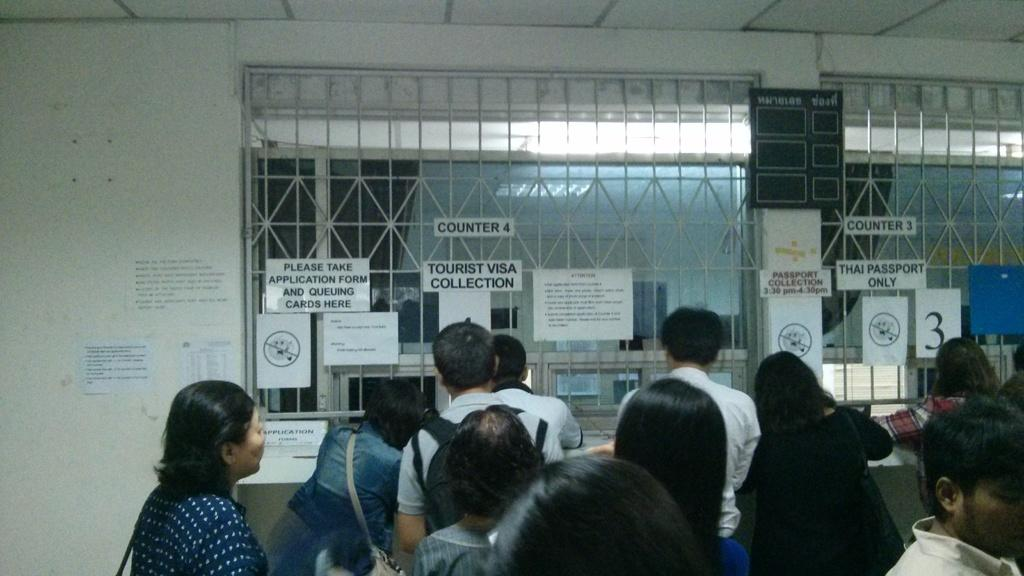What is happening in the image involving people? There is a group of people standing in the image. What can be seen on the wall and railing in the image? There are boards on the wall and railing in the image. What is written or depicted on the boards? There is text on the boards. What is visible at the top of the image? There are lights at the top of the image. How does the woman's belief affect the dust in the image? There is no woman or dust present in the image. What type of belief is depicted in the image? There is no belief depicted in the image; the focus is on the group of people, boards, and lights. 